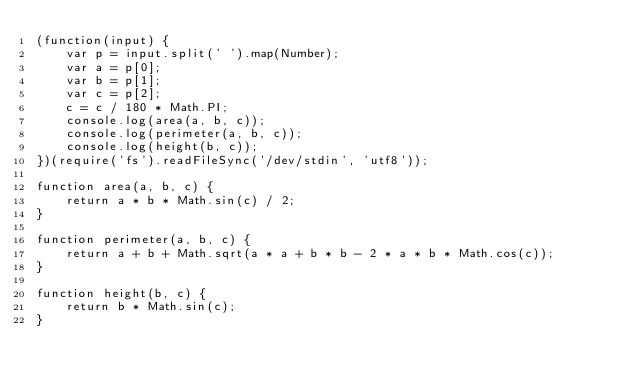Convert code to text. <code><loc_0><loc_0><loc_500><loc_500><_JavaScript_>(function(input) {
    var p = input.split(' ').map(Number);
    var a = p[0];
    var b = p[1];
    var c = p[2];
    c = c / 180 * Math.PI;
    console.log(area(a, b, c));
    console.log(perimeter(a, b, c));
    console.log(height(b, c));
})(require('fs').readFileSync('/dev/stdin', 'utf8'));

function area(a, b, c) {
    return a * b * Math.sin(c) / 2;
}

function perimeter(a, b, c) {
    return a + b + Math.sqrt(a * a + b * b - 2 * a * b * Math.cos(c));
}

function height(b, c) {
    return b * Math.sin(c);
}</code> 